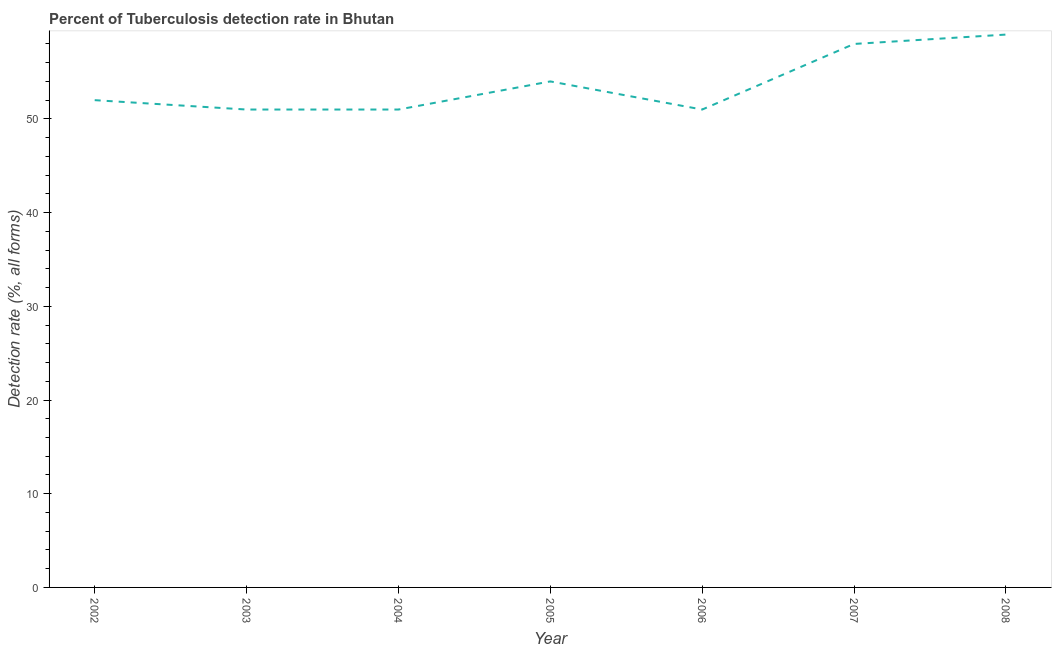Across all years, what is the maximum detection rate of tuberculosis?
Offer a terse response. 59. Across all years, what is the minimum detection rate of tuberculosis?
Ensure brevity in your answer.  51. In which year was the detection rate of tuberculosis minimum?
Offer a very short reply. 2003. What is the sum of the detection rate of tuberculosis?
Your response must be concise. 376. What is the average detection rate of tuberculosis per year?
Offer a terse response. 53.71. What is the median detection rate of tuberculosis?
Offer a very short reply. 52. What is the ratio of the detection rate of tuberculosis in 2003 to that in 2005?
Keep it short and to the point. 0.94. Is the detection rate of tuberculosis in 2006 less than that in 2007?
Your response must be concise. Yes. What is the difference between the highest and the second highest detection rate of tuberculosis?
Your answer should be compact. 1. In how many years, is the detection rate of tuberculosis greater than the average detection rate of tuberculosis taken over all years?
Your answer should be very brief. 3. How many lines are there?
Offer a very short reply. 1. How many years are there in the graph?
Offer a very short reply. 7. What is the difference between two consecutive major ticks on the Y-axis?
Keep it short and to the point. 10. Are the values on the major ticks of Y-axis written in scientific E-notation?
Ensure brevity in your answer.  No. What is the title of the graph?
Offer a terse response. Percent of Tuberculosis detection rate in Bhutan. What is the label or title of the X-axis?
Ensure brevity in your answer.  Year. What is the label or title of the Y-axis?
Your answer should be compact. Detection rate (%, all forms). What is the Detection rate (%, all forms) of 2002?
Provide a short and direct response. 52. What is the Detection rate (%, all forms) of 2004?
Your answer should be compact. 51. What is the Detection rate (%, all forms) in 2005?
Give a very brief answer. 54. What is the Detection rate (%, all forms) of 2007?
Offer a terse response. 58. What is the Detection rate (%, all forms) in 2008?
Give a very brief answer. 59. What is the difference between the Detection rate (%, all forms) in 2002 and 2003?
Provide a short and direct response. 1. What is the difference between the Detection rate (%, all forms) in 2002 and 2006?
Keep it short and to the point. 1. What is the difference between the Detection rate (%, all forms) in 2002 and 2008?
Your response must be concise. -7. What is the difference between the Detection rate (%, all forms) in 2003 and 2005?
Provide a succinct answer. -3. What is the difference between the Detection rate (%, all forms) in 2003 and 2007?
Provide a succinct answer. -7. What is the difference between the Detection rate (%, all forms) in 2004 and 2006?
Offer a very short reply. 0. What is the difference between the Detection rate (%, all forms) in 2004 and 2007?
Make the answer very short. -7. What is the difference between the Detection rate (%, all forms) in 2004 and 2008?
Make the answer very short. -8. What is the difference between the Detection rate (%, all forms) in 2005 and 2007?
Provide a short and direct response. -4. What is the difference between the Detection rate (%, all forms) in 2006 and 2008?
Give a very brief answer. -8. What is the difference between the Detection rate (%, all forms) in 2007 and 2008?
Your answer should be compact. -1. What is the ratio of the Detection rate (%, all forms) in 2002 to that in 2005?
Offer a terse response. 0.96. What is the ratio of the Detection rate (%, all forms) in 2002 to that in 2007?
Your answer should be very brief. 0.9. What is the ratio of the Detection rate (%, all forms) in 2002 to that in 2008?
Ensure brevity in your answer.  0.88. What is the ratio of the Detection rate (%, all forms) in 2003 to that in 2005?
Your answer should be very brief. 0.94. What is the ratio of the Detection rate (%, all forms) in 2003 to that in 2006?
Provide a succinct answer. 1. What is the ratio of the Detection rate (%, all forms) in 2003 to that in 2007?
Offer a very short reply. 0.88. What is the ratio of the Detection rate (%, all forms) in 2003 to that in 2008?
Give a very brief answer. 0.86. What is the ratio of the Detection rate (%, all forms) in 2004 to that in 2005?
Keep it short and to the point. 0.94. What is the ratio of the Detection rate (%, all forms) in 2004 to that in 2006?
Keep it short and to the point. 1. What is the ratio of the Detection rate (%, all forms) in 2004 to that in 2007?
Your answer should be very brief. 0.88. What is the ratio of the Detection rate (%, all forms) in 2004 to that in 2008?
Your answer should be compact. 0.86. What is the ratio of the Detection rate (%, all forms) in 2005 to that in 2006?
Provide a succinct answer. 1.06. What is the ratio of the Detection rate (%, all forms) in 2005 to that in 2008?
Give a very brief answer. 0.92. What is the ratio of the Detection rate (%, all forms) in 2006 to that in 2007?
Your answer should be very brief. 0.88. What is the ratio of the Detection rate (%, all forms) in 2006 to that in 2008?
Ensure brevity in your answer.  0.86. What is the ratio of the Detection rate (%, all forms) in 2007 to that in 2008?
Provide a short and direct response. 0.98. 